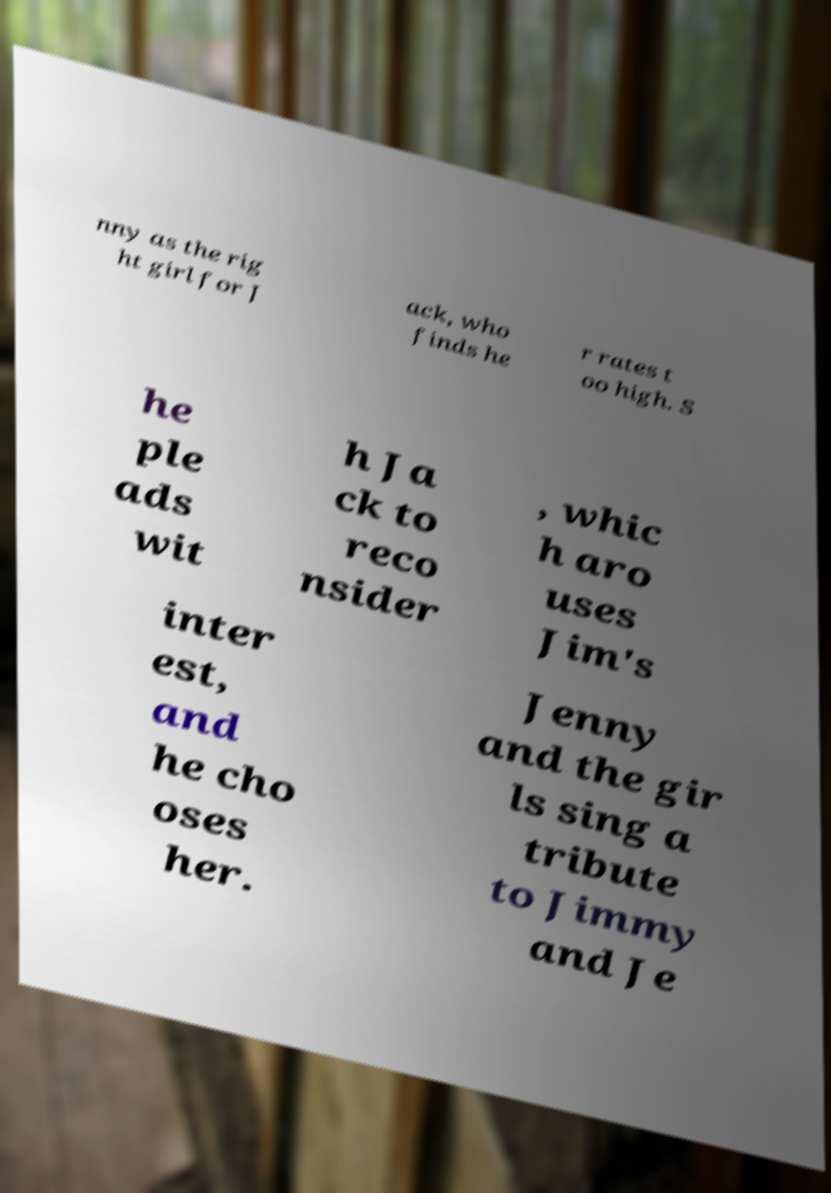Can you accurately transcribe the text from the provided image for me? nny as the rig ht girl for J ack, who finds he r rates t oo high. S he ple ads wit h Ja ck to reco nsider , whic h aro uses Jim's inter est, and he cho oses her. Jenny and the gir ls sing a tribute to Jimmy and Je 